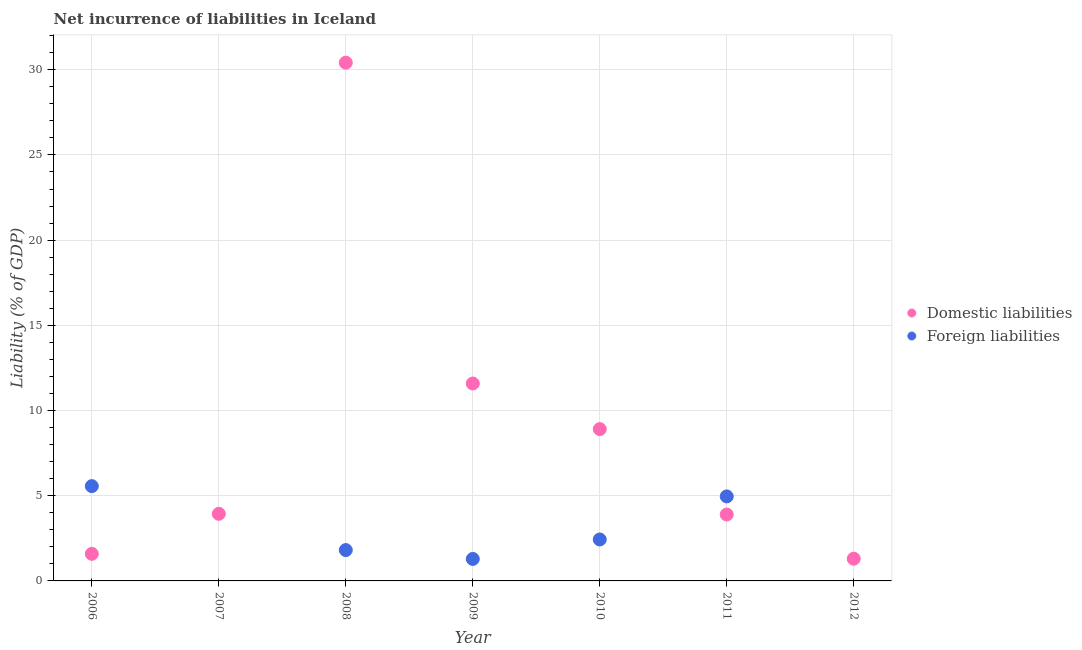How many different coloured dotlines are there?
Ensure brevity in your answer.  2. Is the number of dotlines equal to the number of legend labels?
Give a very brief answer. No. What is the incurrence of foreign liabilities in 2011?
Give a very brief answer. 4.96. Across all years, what is the maximum incurrence of domestic liabilities?
Offer a very short reply. 30.41. In which year was the incurrence of foreign liabilities maximum?
Offer a terse response. 2006. What is the total incurrence of foreign liabilities in the graph?
Keep it short and to the point. 16.06. What is the difference between the incurrence of domestic liabilities in 2007 and that in 2011?
Your response must be concise. 0.04. What is the difference between the incurrence of foreign liabilities in 2006 and the incurrence of domestic liabilities in 2009?
Provide a succinct answer. -6.02. What is the average incurrence of domestic liabilities per year?
Make the answer very short. 8.81. In the year 2010, what is the difference between the incurrence of foreign liabilities and incurrence of domestic liabilities?
Offer a terse response. -6.48. What is the ratio of the incurrence of domestic liabilities in 2007 to that in 2010?
Give a very brief answer. 0.44. Is the incurrence of domestic liabilities in 2006 less than that in 2009?
Keep it short and to the point. Yes. Is the difference between the incurrence of domestic liabilities in 2008 and 2011 greater than the difference between the incurrence of foreign liabilities in 2008 and 2011?
Your answer should be compact. Yes. What is the difference between the highest and the second highest incurrence of foreign liabilities?
Ensure brevity in your answer.  0.6. What is the difference between the highest and the lowest incurrence of domestic liabilities?
Offer a very short reply. 29.11. In how many years, is the incurrence of foreign liabilities greater than the average incurrence of foreign liabilities taken over all years?
Keep it short and to the point. 3. Does the incurrence of domestic liabilities monotonically increase over the years?
Provide a short and direct response. No. Is the incurrence of domestic liabilities strictly greater than the incurrence of foreign liabilities over the years?
Your answer should be compact. No. How many years are there in the graph?
Provide a short and direct response. 7. What is the difference between two consecutive major ticks on the Y-axis?
Your answer should be very brief. 5. How many legend labels are there?
Offer a terse response. 2. How are the legend labels stacked?
Provide a short and direct response. Vertical. What is the title of the graph?
Your response must be concise. Net incurrence of liabilities in Iceland. Does "Primary education" appear as one of the legend labels in the graph?
Provide a short and direct response. No. What is the label or title of the X-axis?
Keep it short and to the point. Year. What is the label or title of the Y-axis?
Provide a succinct answer. Liability (% of GDP). What is the Liability (% of GDP) in Domestic liabilities in 2006?
Offer a terse response. 1.59. What is the Liability (% of GDP) of Foreign liabilities in 2006?
Make the answer very short. 5.56. What is the Liability (% of GDP) in Domestic liabilities in 2007?
Your response must be concise. 3.94. What is the Liability (% of GDP) of Domestic liabilities in 2008?
Keep it short and to the point. 30.41. What is the Liability (% of GDP) of Foreign liabilities in 2008?
Make the answer very short. 1.81. What is the Liability (% of GDP) in Domestic liabilities in 2009?
Provide a short and direct response. 11.59. What is the Liability (% of GDP) of Foreign liabilities in 2009?
Make the answer very short. 1.29. What is the Liability (% of GDP) of Domestic liabilities in 2010?
Your answer should be compact. 8.91. What is the Liability (% of GDP) in Foreign liabilities in 2010?
Keep it short and to the point. 2.43. What is the Liability (% of GDP) of Domestic liabilities in 2011?
Offer a very short reply. 3.9. What is the Liability (% of GDP) of Foreign liabilities in 2011?
Ensure brevity in your answer.  4.96. What is the Liability (% of GDP) of Domestic liabilities in 2012?
Make the answer very short. 1.3. Across all years, what is the maximum Liability (% of GDP) in Domestic liabilities?
Keep it short and to the point. 30.41. Across all years, what is the maximum Liability (% of GDP) in Foreign liabilities?
Make the answer very short. 5.56. Across all years, what is the minimum Liability (% of GDP) of Domestic liabilities?
Provide a succinct answer. 1.3. Across all years, what is the minimum Liability (% of GDP) of Foreign liabilities?
Offer a very short reply. 0. What is the total Liability (% of GDP) of Domestic liabilities in the graph?
Keep it short and to the point. 61.64. What is the total Liability (% of GDP) in Foreign liabilities in the graph?
Offer a very short reply. 16.06. What is the difference between the Liability (% of GDP) in Domestic liabilities in 2006 and that in 2007?
Offer a very short reply. -2.35. What is the difference between the Liability (% of GDP) in Domestic liabilities in 2006 and that in 2008?
Ensure brevity in your answer.  -28.82. What is the difference between the Liability (% of GDP) of Foreign liabilities in 2006 and that in 2008?
Provide a short and direct response. 3.75. What is the difference between the Liability (% of GDP) in Domestic liabilities in 2006 and that in 2009?
Keep it short and to the point. -10. What is the difference between the Liability (% of GDP) in Foreign liabilities in 2006 and that in 2009?
Ensure brevity in your answer.  4.27. What is the difference between the Liability (% of GDP) of Domestic liabilities in 2006 and that in 2010?
Make the answer very short. -7.32. What is the difference between the Liability (% of GDP) of Foreign liabilities in 2006 and that in 2010?
Offer a terse response. 3.13. What is the difference between the Liability (% of GDP) of Domestic liabilities in 2006 and that in 2011?
Keep it short and to the point. -2.31. What is the difference between the Liability (% of GDP) in Foreign liabilities in 2006 and that in 2011?
Your answer should be very brief. 0.6. What is the difference between the Liability (% of GDP) of Domestic liabilities in 2006 and that in 2012?
Your response must be concise. 0.29. What is the difference between the Liability (% of GDP) in Domestic liabilities in 2007 and that in 2008?
Make the answer very short. -26.48. What is the difference between the Liability (% of GDP) in Domestic liabilities in 2007 and that in 2009?
Your answer should be compact. -7.65. What is the difference between the Liability (% of GDP) in Domestic liabilities in 2007 and that in 2010?
Ensure brevity in your answer.  -4.97. What is the difference between the Liability (% of GDP) of Domestic liabilities in 2007 and that in 2011?
Provide a succinct answer. 0.04. What is the difference between the Liability (% of GDP) of Domestic liabilities in 2007 and that in 2012?
Keep it short and to the point. 2.63. What is the difference between the Liability (% of GDP) in Domestic liabilities in 2008 and that in 2009?
Give a very brief answer. 18.83. What is the difference between the Liability (% of GDP) of Foreign liabilities in 2008 and that in 2009?
Make the answer very short. 0.52. What is the difference between the Liability (% of GDP) in Domestic liabilities in 2008 and that in 2010?
Make the answer very short. 21.51. What is the difference between the Liability (% of GDP) in Foreign liabilities in 2008 and that in 2010?
Provide a short and direct response. -0.62. What is the difference between the Liability (% of GDP) in Domestic liabilities in 2008 and that in 2011?
Make the answer very short. 26.52. What is the difference between the Liability (% of GDP) of Foreign liabilities in 2008 and that in 2011?
Provide a succinct answer. -3.15. What is the difference between the Liability (% of GDP) of Domestic liabilities in 2008 and that in 2012?
Offer a terse response. 29.11. What is the difference between the Liability (% of GDP) of Domestic liabilities in 2009 and that in 2010?
Offer a very short reply. 2.68. What is the difference between the Liability (% of GDP) in Foreign liabilities in 2009 and that in 2010?
Provide a succinct answer. -1.14. What is the difference between the Liability (% of GDP) of Domestic liabilities in 2009 and that in 2011?
Ensure brevity in your answer.  7.69. What is the difference between the Liability (% of GDP) of Foreign liabilities in 2009 and that in 2011?
Your answer should be compact. -3.67. What is the difference between the Liability (% of GDP) of Domestic liabilities in 2009 and that in 2012?
Keep it short and to the point. 10.28. What is the difference between the Liability (% of GDP) of Domestic liabilities in 2010 and that in 2011?
Provide a succinct answer. 5.01. What is the difference between the Liability (% of GDP) of Foreign liabilities in 2010 and that in 2011?
Ensure brevity in your answer.  -2.53. What is the difference between the Liability (% of GDP) in Domestic liabilities in 2010 and that in 2012?
Provide a short and direct response. 7.6. What is the difference between the Liability (% of GDP) in Domestic liabilities in 2011 and that in 2012?
Your answer should be compact. 2.59. What is the difference between the Liability (% of GDP) in Domestic liabilities in 2006 and the Liability (% of GDP) in Foreign liabilities in 2008?
Your answer should be very brief. -0.22. What is the difference between the Liability (% of GDP) in Domestic liabilities in 2006 and the Liability (% of GDP) in Foreign liabilities in 2009?
Provide a short and direct response. 0.3. What is the difference between the Liability (% of GDP) of Domestic liabilities in 2006 and the Liability (% of GDP) of Foreign liabilities in 2010?
Your answer should be compact. -0.84. What is the difference between the Liability (% of GDP) in Domestic liabilities in 2006 and the Liability (% of GDP) in Foreign liabilities in 2011?
Keep it short and to the point. -3.37. What is the difference between the Liability (% of GDP) of Domestic liabilities in 2007 and the Liability (% of GDP) of Foreign liabilities in 2008?
Provide a succinct answer. 2.13. What is the difference between the Liability (% of GDP) of Domestic liabilities in 2007 and the Liability (% of GDP) of Foreign liabilities in 2009?
Your answer should be very brief. 2.65. What is the difference between the Liability (% of GDP) in Domestic liabilities in 2007 and the Liability (% of GDP) in Foreign liabilities in 2010?
Ensure brevity in your answer.  1.51. What is the difference between the Liability (% of GDP) in Domestic liabilities in 2007 and the Liability (% of GDP) in Foreign liabilities in 2011?
Give a very brief answer. -1.02. What is the difference between the Liability (% of GDP) of Domestic liabilities in 2008 and the Liability (% of GDP) of Foreign liabilities in 2009?
Offer a terse response. 29.12. What is the difference between the Liability (% of GDP) of Domestic liabilities in 2008 and the Liability (% of GDP) of Foreign liabilities in 2010?
Make the answer very short. 27.98. What is the difference between the Liability (% of GDP) of Domestic liabilities in 2008 and the Liability (% of GDP) of Foreign liabilities in 2011?
Ensure brevity in your answer.  25.45. What is the difference between the Liability (% of GDP) in Domestic liabilities in 2009 and the Liability (% of GDP) in Foreign liabilities in 2010?
Your response must be concise. 9.15. What is the difference between the Liability (% of GDP) in Domestic liabilities in 2009 and the Liability (% of GDP) in Foreign liabilities in 2011?
Provide a short and direct response. 6.63. What is the difference between the Liability (% of GDP) in Domestic liabilities in 2010 and the Liability (% of GDP) in Foreign liabilities in 2011?
Ensure brevity in your answer.  3.95. What is the average Liability (% of GDP) of Domestic liabilities per year?
Offer a very short reply. 8.81. What is the average Liability (% of GDP) of Foreign liabilities per year?
Offer a very short reply. 2.29. In the year 2006, what is the difference between the Liability (% of GDP) in Domestic liabilities and Liability (% of GDP) in Foreign liabilities?
Your answer should be compact. -3.97. In the year 2008, what is the difference between the Liability (% of GDP) in Domestic liabilities and Liability (% of GDP) in Foreign liabilities?
Keep it short and to the point. 28.6. In the year 2009, what is the difference between the Liability (% of GDP) in Domestic liabilities and Liability (% of GDP) in Foreign liabilities?
Offer a terse response. 10.29. In the year 2010, what is the difference between the Liability (% of GDP) of Domestic liabilities and Liability (% of GDP) of Foreign liabilities?
Keep it short and to the point. 6.48. In the year 2011, what is the difference between the Liability (% of GDP) of Domestic liabilities and Liability (% of GDP) of Foreign liabilities?
Your answer should be very brief. -1.06. What is the ratio of the Liability (% of GDP) of Domestic liabilities in 2006 to that in 2007?
Offer a terse response. 0.4. What is the ratio of the Liability (% of GDP) of Domestic liabilities in 2006 to that in 2008?
Your response must be concise. 0.05. What is the ratio of the Liability (% of GDP) in Foreign liabilities in 2006 to that in 2008?
Offer a terse response. 3.07. What is the ratio of the Liability (% of GDP) in Domestic liabilities in 2006 to that in 2009?
Offer a very short reply. 0.14. What is the ratio of the Liability (% of GDP) of Foreign liabilities in 2006 to that in 2009?
Provide a succinct answer. 4.31. What is the ratio of the Liability (% of GDP) in Domestic liabilities in 2006 to that in 2010?
Your answer should be very brief. 0.18. What is the ratio of the Liability (% of GDP) in Foreign liabilities in 2006 to that in 2010?
Offer a very short reply. 2.29. What is the ratio of the Liability (% of GDP) of Domestic liabilities in 2006 to that in 2011?
Make the answer very short. 0.41. What is the ratio of the Liability (% of GDP) of Foreign liabilities in 2006 to that in 2011?
Make the answer very short. 1.12. What is the ratio of the Liability (% of GDP) in Domestic liabilities in 2006 to that in 2012?
Offer a terse response. 1.22. What is the ratio of the Liability (% of GDP) in Domestic liabilities in 2007 to that in 2008?
Offer a very short reply. 0.13. What is the ratio of the Liability (% of GDP) of Domestic liabilities in 2007 to that in 2009?
Provide a short and direct response. 0.34. What is the ratio of the Liability (% of GDP) of Domestic liabilities in 2007 to that in 2010?
Offer a terse response. 0.44. What is the ratio of the Liability (% of GDP) in Domestic liabilities in 2007 to that in 2011?
Provide a succinct answer. 1.01. What is the ratio of the Liability (% of GDP) in Domestic liabilities in 2007 to that in 2012?
Keep it short and to the point. 3.02. What is the ratio of the Liability (% of GDP) of Domestic liabilities in 2008 to that in 2009?
Your answer should be very brief. 2.63. What is the ratio of the Liability (% of GDP) in Foreign liabilities in 2008 to that in 2009?
Make the answer very short. 1.4. What is the ratio of the Liability (% of GDP) of Domestic liabilities in 2008 to that in 2010?
Your response must be concise. 3.41. What is the ratio of the Liability (% of GDP) in Foreign liabilities in 2008 to that in 2010?
Keep it short and to the point. 0.74. What is the ratio of the Liability (% of GDP) in Domestic liabilities in 2008 to that in 2011?
Make the answer very short. 7.8. What is the ratio of the Liability (% of GDP) in Foreign liabilities in 2008 to that in 2011?
Give a very brief answer. 0.37. What is the ratio of the Liability (% of GDP) in Domestic liabilities in 2008 to that in 2012?
Keep it short and to the point. 23.33. What is the ratio of the Liability (% of GDP) of Domestic liabilities in 2009 to that in 2010?
Your response must be concise. 1.3. What is the ratio of the Liability (% of GDP) of Foreign liabilities in 2009 to that in 2010?
Provide a short and direct response. 0.53. What is the ratio of the Liability (% of GDP) in Domestic liabilities in 2009 to that in 2011?
Ensure brevity in your answer.  2.97. What is the ratio of the Liability (% of GDP) of Foreign liabilities in 2009 to that in 2011?
Ensure brevity in your answer.  0.26. What is the ratio of the Liability (% of GDP) in Domestic liabilities in 2009 to that in 2012?
Provide a succinct answer. 8.89. What is the ratio of the Liability (% of GDP) of Domestic liabilities in 2010 to that in 2011?
Provide a short and direct response. 2.29. What is the ratio of the Liability (% of GDP) of Foreign liabilities in 2010 to that in 2011?
Your answer should be very brief. 0.49. What is the ratio of the Liability (% of GDP) of Domestic liabilities in 2010 to that in 2012?
Provide a short and direct response. 6.83. What is the ratio of the Liability (% of GDP) of Domestic liabilities in 2011 to that in 2012?
Ensure brevity in your answer.  2.99. What is the difference between the highest and the second highest Liability (% of GDP) in Domestic liabilities?
Offer a terse response. 18.83. What is the difference between the highest and the second highest Liability (% of GDP) in Foreign liabilities?
Offer a very short reply. 0.6. What is the difference between the highest and the lowest Liability (% of GDP) of Domestic liabilities?
Your answer should be compact. 29.11. What is the difference between the highest and the lowest Liability (% of GDP) in Foreign liabilities?
Make the answer very short. 5.56. 